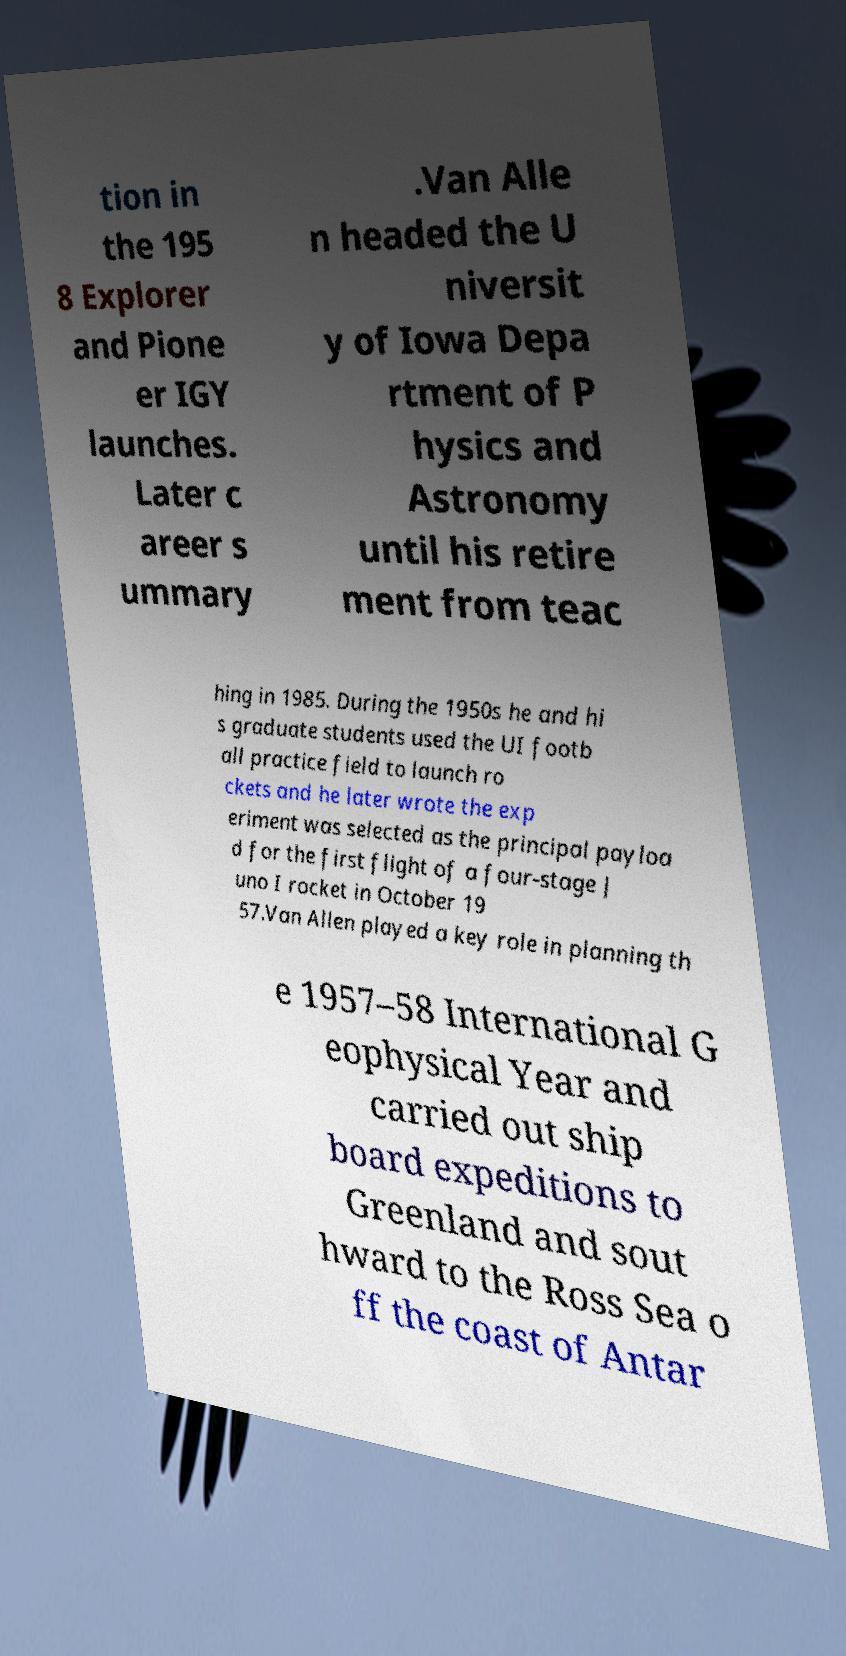For documentation purposes, I need the text within this image transcribed. Could you provide that? tion in the 195 8 Explorer and Pione er IGY launches. Later c areer s ummary .Van Alle n headed the U niversit y of Iowa Depa rtment of P hysics and Astronomy until his retire ment from teac hing in 1985. During the 1950s he and hi s graduate students used the UI footb all practice field to launch ro ckets and he later wrote the exp eriment was selected as the principal payloa d for the first flight of a four-stage J uno I rocket in October 19 57.Van Allen played a key role in planning th e 1957–58 International G eophysical Year and carried out ship board expeditions to Greenland and sout hward to the Ross Sea o ff the coast of Antar 